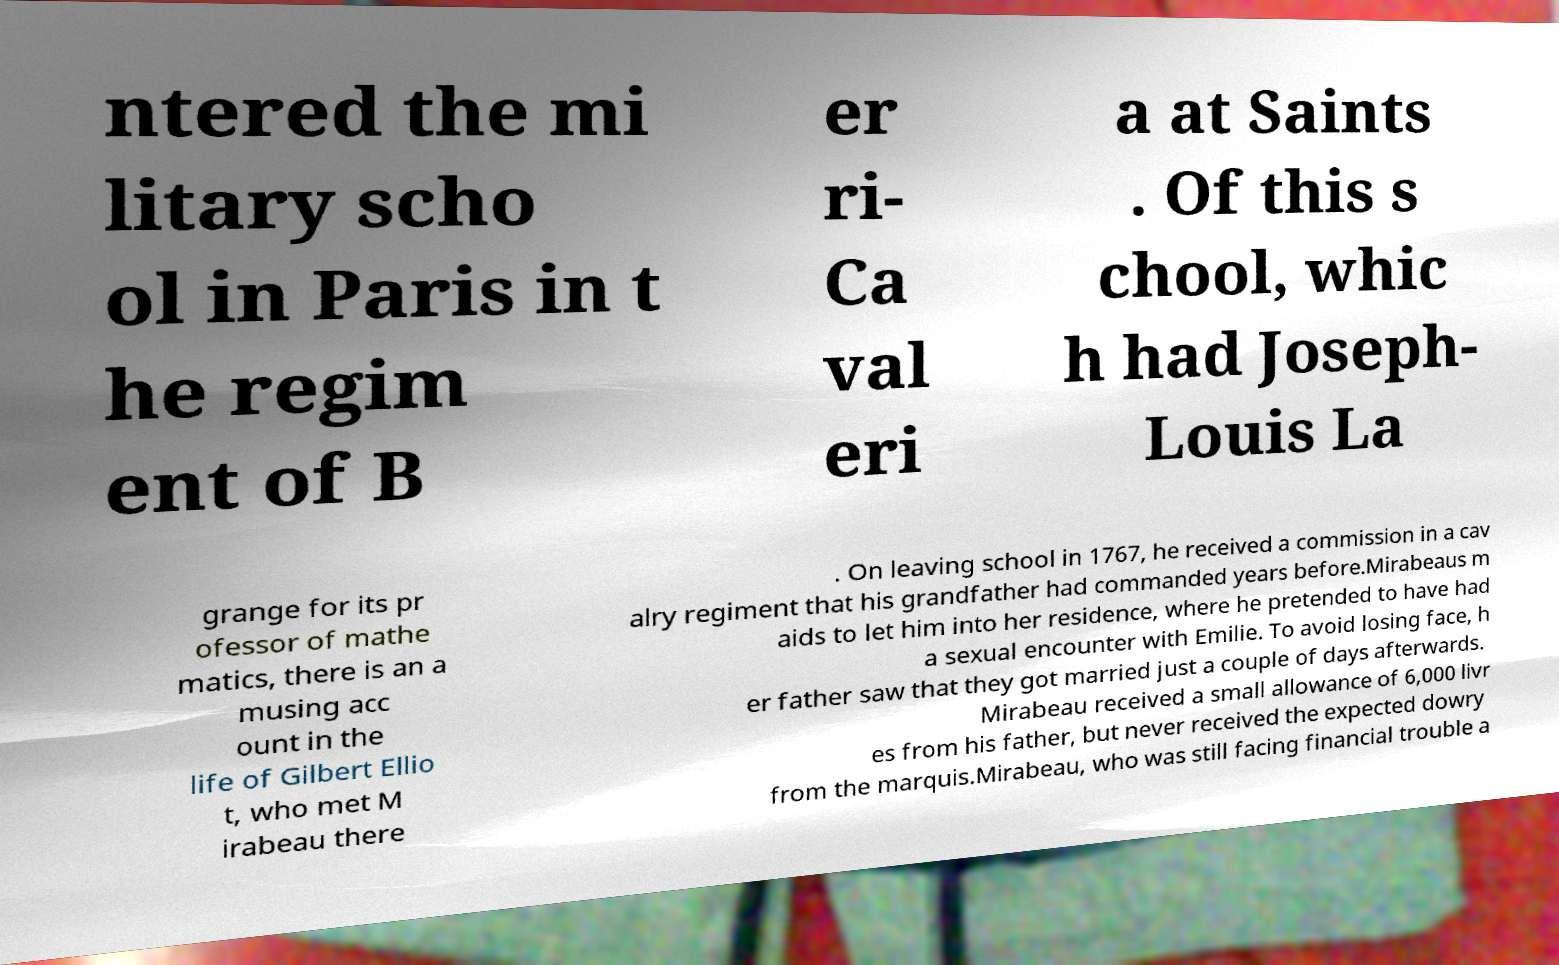For documentation purposes, I need the text within this image transcribed. Could you provide that? ntered the mi litary scho ol in Paris in t he regim ent of B er ri- Ca val eri a at Saints . Of this s chool, whic h had Joseph- Louis La grange for its pr ofessor of mathe matics, there is an a musing acc ount in the life of Gilbert Ellio t, who met M irabeau there . On leaving school in 1767, he received a commission in a cav alry regiment that his grandfather had commanded years before.Mirabeaus m aids to let him into her residence, where he pretended to have had a sexual encounter with Emilie. To avoid losing face, h er father saw that they got married just a couple of days afterwards. Mirabeau received a small allowance of 6,000 livr es from his father, but never received the expected dowry from the marquis.Mirabeau, who was still facing financial trouble a 